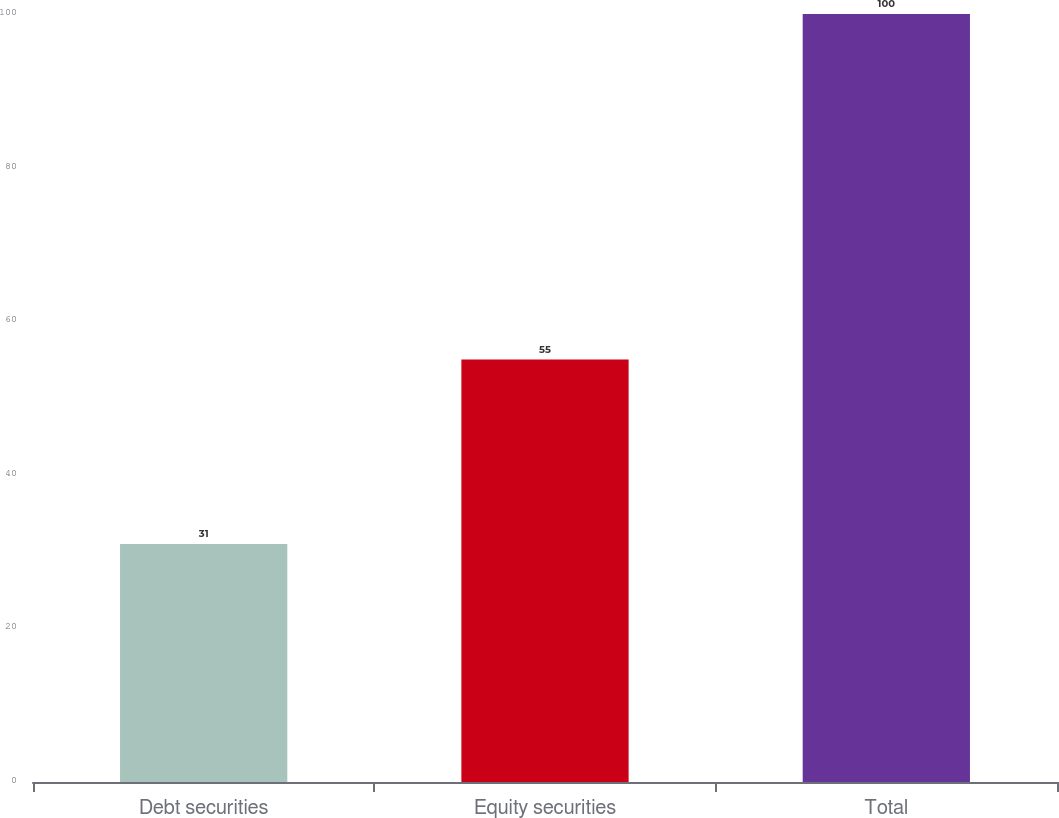<chart> <loc_0><loc_0><loc_500><loc_500><bar_chart><fcel>Debt securities<fcel>Equity securities<fcel>Total<nl><fcel>31<fcel>55<fcel>100<nl></chart> 